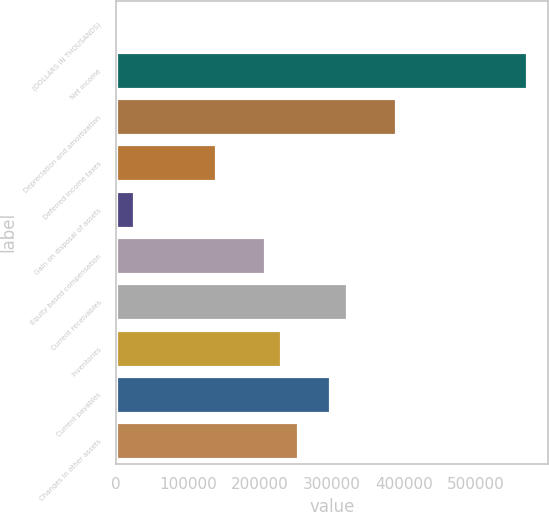<chart> <loc_0><loc_0><loc_500><loc_500><bar_chart><fcel>(DOLLARS IN THOUSANDS)<fcel>Net income<fcel>Depreciation and amortization<fcel>Deferred income taxes<fcel>Gain on disposal of assets<fcel>Equity based compensation<fcel>Current receivables<fcel>Inventories<fcel>Current payables<fcel>Changes in other assets<nl><fcel>2008<fcel>571058<fcel>388962<fcel>138580<fcel>24770<fcel>206866<fcel>320676<fcel>229628<fcel>297914<fcel>252390<nl></chart> 